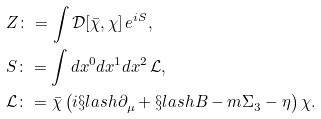Convert formula to latex. <formula><loc_0><loc_0><loc_500><loc_500>& Z \colon = \int \mathcal { D } [ \bar { \chi } , \chi ] \, e ^ { { i } S } , \\ & S \colon = \int d x ^ { 0 } d x ^ { 1 } d x ^ { 2 } \, \mathcal { L } , \\ & \mathcal { L } \colon = \bar { \chi } \left ( { i } \S l a s h { \partial } ^ { \ } _ { \mu } + \S l a s h { B } - m \Sigma ^ { \ } _ { 3 } - \eta \right ) \chi .</formula> 